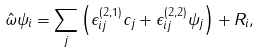<formula> <loc_0><loc_0><loc_500><loc_500>\hat { \omega } \psi _ { i } = \sum _ { j } \left ( \epsilon ^ { ( 2 , 1 ) } _ { i j } c _ { j } + \epsilon ^ { ( 2 , 2 ) } _ { i j } \psi _ { j } \right ) + \mathit { R _ { i } } ,</formula> 